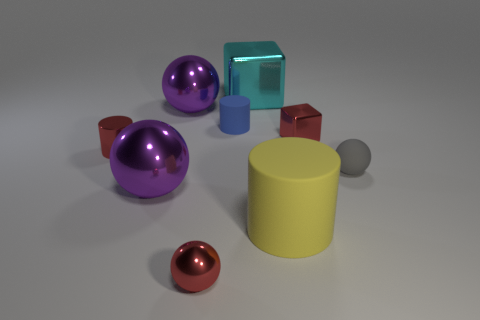The other small object that is the same shape as the gray thing is what color? red 